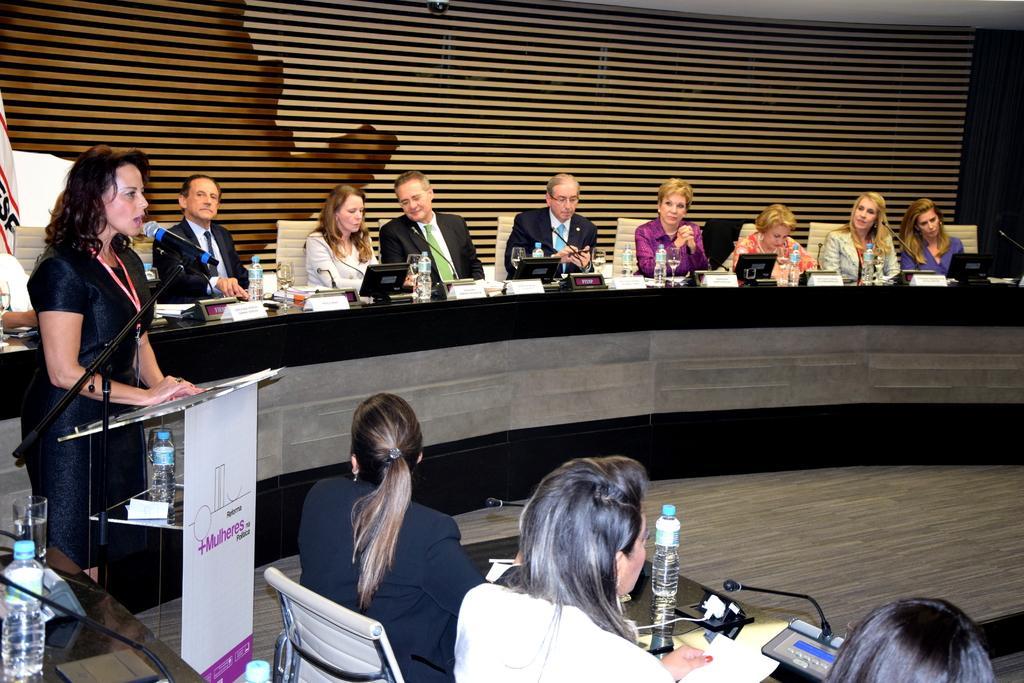Please provide a concise description of this image. the picture there is a room in that room there are many people sitting on a chair with table on in front of them a woman standing near the podium and talking in the microphone which is in front of her on the table there are many things such as bottles laptops papers e. t. c. 